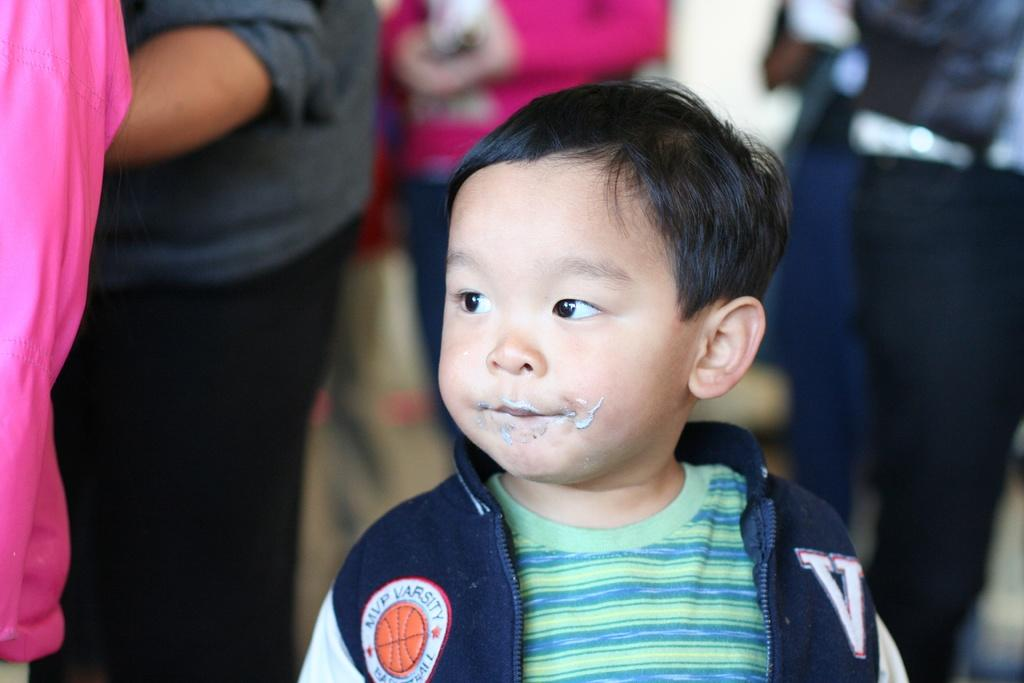Provide a one-sentence caption for the provided image. A little asian boy standing wearing a jacket with a V on it. 